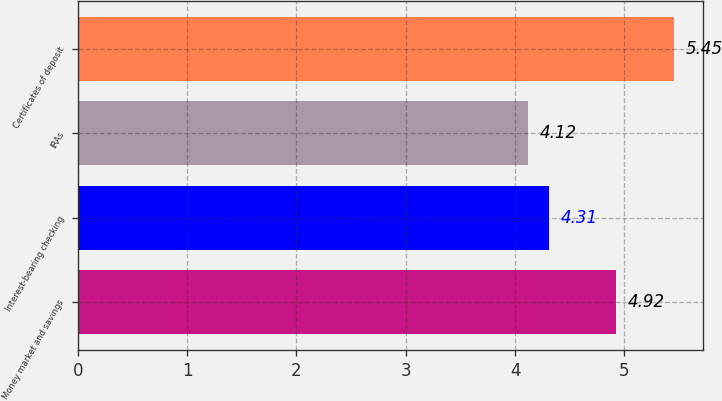Convert chart to OTSL. <chart><loc_0><loc_0><loc_500><loc_500><bar_chart><fcel>Money market and savings<fcel>Interest-bearing checking<fcel>IRAs<fcel>Certificates of deposit<nl><fcel>4.92<fcel>4.31<fcel>4.12<fcel>5.45<nl></chart> 